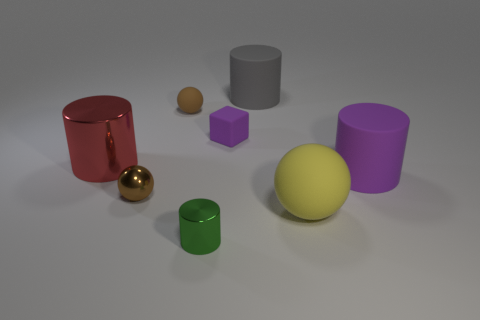Add 2 gray cylinders. How many objects exist? 10 Subtract all balls. How many objects are left? 5 Subtract all green things. Subtract all spheres. How many objects are left? 4 Add 8 small brown balls. How many small brown balls are left? 10 Add 3 yellow rubber spheres. How many yellow rubber spheres exist? 4 Subtract 0 red spheres. How many objects are left? 8 